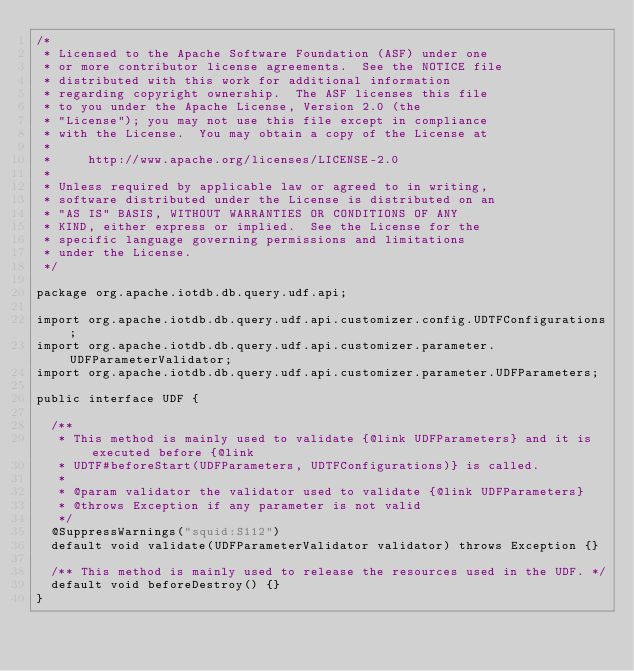<code> <loc_0><loc_0><loc_500><loc_500><_Java_>/*
 * Licensed to the Apache Software Foundation (ASF) under one
 * or more contributor license agreements.  See the NOTICE file
 * distributed with this work for additional information
 * regarding copyright ownership.  The ASF licenses this file
 * to you under the Apache License, Version 2.0 (the
 * "License"); you may not use this file except in compliance
 * with the License.  You may obtain a copy of the License at
 *
 *     http://www.apache.org/licenses/LICENSE-2.0
 *
 * Unless required by applicable law or agreed to in writing,
 * software distributed under the License is distributed on an
 * "AS IS" BASIS, WITHOUT WARRANTIES OR CONDITIONS OF ANY
 * KIND, either express or implied.  See the License for the
 * specific language governing permissions and limitations
 * under the License.
 */

package org.apache.iotdb.db.query.udf.api;

import org.apache.iotdb.db.query.udf.api.customizer.config.UDTFConfigurations;
import org.apache.iotdb.db.query.udf.api.customizer.parameter.UDFParameterValidator;
import org.apache.iotdb.db.query.udf.api.customizer.parameter.UDFParameters;

public interface UDF {

  /**
   * This method is mainly used to validate {@link UDFParameters} and it is executed before {@link
   * UDTF#beforeStart(UDFParameters, UDTFConfigurations)} is called.
   *
   * @param validator the validator used to validate {@link UDFParameters}
   * @throws Exception if any parameter is not valid
   */
  @SuppressWarnings("squid:S112")
  default void validate(UDFParameterValidator validator) throws Exception {}

  /** This method is mainly used to release the resources used in the UDF. */
  default void beforeDestroy() {}
}
</code> 